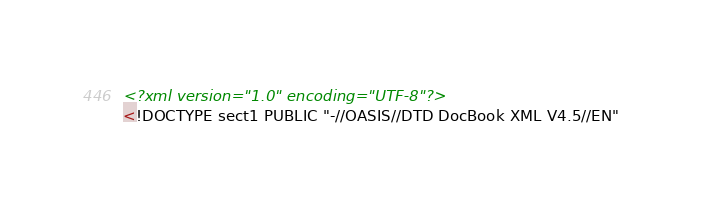Convert code to text. <code><loc_0><loc_0><loc_500><loc_500><_XML_><?xml version="1.0" encoding="UTF-8"?>
<!DOCTYPE sect1 PUBLIC "-//OASIS//DTD DocBook XML V4.5//EN"</code> 